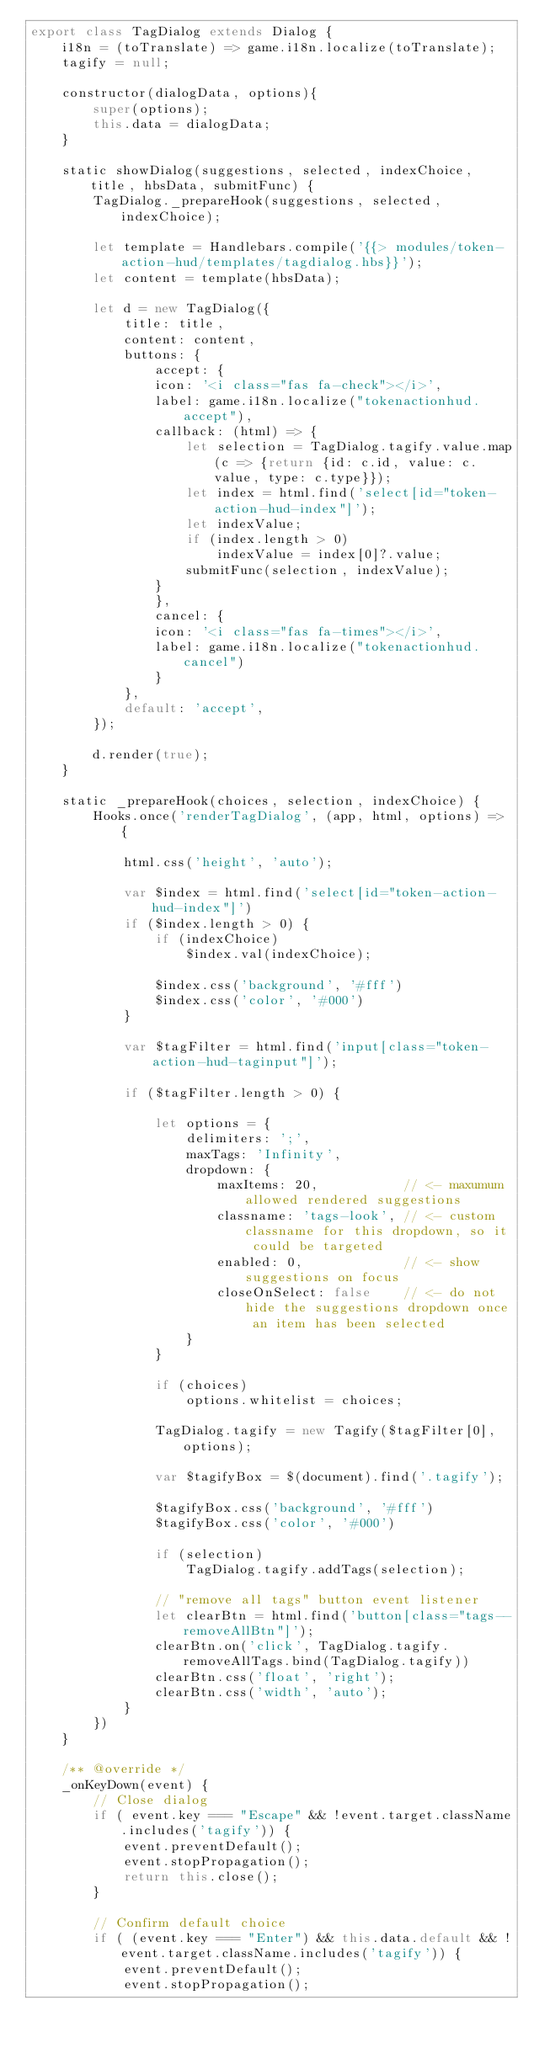<code> <loc_0><loc_0><loc_500><loc_500><_JavaScript_>export class TagDialog extends Dialog {
    i18n = (toTranslate) => game.i18n.localize(toTranslate);
    tagify = null;

    constructor(dialogData, options){
        super(options);
        this.data = dialogData;
    }
    
    static showDialog(suggestions, selected, indexChoice, title, hbsData, submitFunc) {
        TagDialog._prepareHook(suggestions, selected, indexChoice);
        
        let template = Handlebars.compile('{{> modules/token-action-hud/templates/tagdialog.hbs}}');
        let content = template(hbsData);

        let d = new TagDialog({
            title: title,
            content: content,
            buttons: {
                accept: {
                icon: '<i class="fas fa-check"></i>',
                label: game.i18n.localize("tokenactionhud.accept"),
                callback: (html) => {
                    let selection = TagDialog.tagify.value.map(c => {return {id: c.id, value: c.value, type: c.type}});
                    let index = html.find('select[id="token-action-hud-index"]');
                    let indexValue;
                    if (index.length > 0)
                        indexValue = index[0]?.value;
                    submitFunc(selection, indexValue);
                }
                },
                cancel: {
                icon: '<i class="fas fa-times"></i>',
                label: game.i18n.localize("tokenactionhud.cancel")
                }
            },
            default: 'accept',
        });

        d.render(true);
    }

    static _prepareHook(choices, selection, indexChoice) {
        Hooks.once('renderTagDialog', (app, html, options) => {

            html.css('height', 'auto');

            var $index = html.find('select[id="token-action-hud-index"]')
            if ($index.length > 0) {
                if (indexChoice)
                    $index.val(indexChoice);

                $index.css('background', '#fff')
                $index.css('color', '#000')
            }

            var $tagFilter = html.find('input[class="token-action-hud-taginput"]');
            
            if ($tagFilter.length > 0) {

                let options = {
                    delimiters: ';',
                    maxTags: 'Infinity',
                    dropdown: {
                        maxItems: 20,           // <- maxumum allowed rendered suggestions
                        classname: 'tags-look', // <- custom classname for this dropdown, so it could be targeted
                        enabled: 0,             // <- show suggestions on focus
                        closeOnSelect: false    // <- do not hide the suggestions dropdown once an item has been selected
                    }
                }

                if (choices)
                    options.whitelist = choices;

                TagDialog.tagify = new Tagify($tagFilter[0], options);

                var $tagifyBox = $(document).find('.tagify');

                $tagifyBox.css('background', '#fff')
                $tagifyBox.css('color', '#000')

                if (selection)
                    TagDialog.tagify.addTags(selection);

                // "remove all tags" button event listener
                let clearBtn = html.find('button[class="tags--removeAllBtn"]');
                clearBtn.on('click', TagDialog.tagify.removeAllTags.bind(TagDialog.tagify))
                clearBtn.css('float', 'right');
                clearBtn.css('width', 'auto');
            }
        })
    }

    /** @override */
    _onKeyDown(event) {
        // Close dialog
        if ( event.key === "Escape" && !event.target.className.includes('tagify')) {
            event.preventDefault();
            event.stopPropagation();
            return this.close();
        }
    
        // Confirm default choice
        if ( (event.key === "Enter") && this.data.default && !event.target.className.includes('tagify')) {
            event.preventDefault();
            event.stopPropagation();</code> 